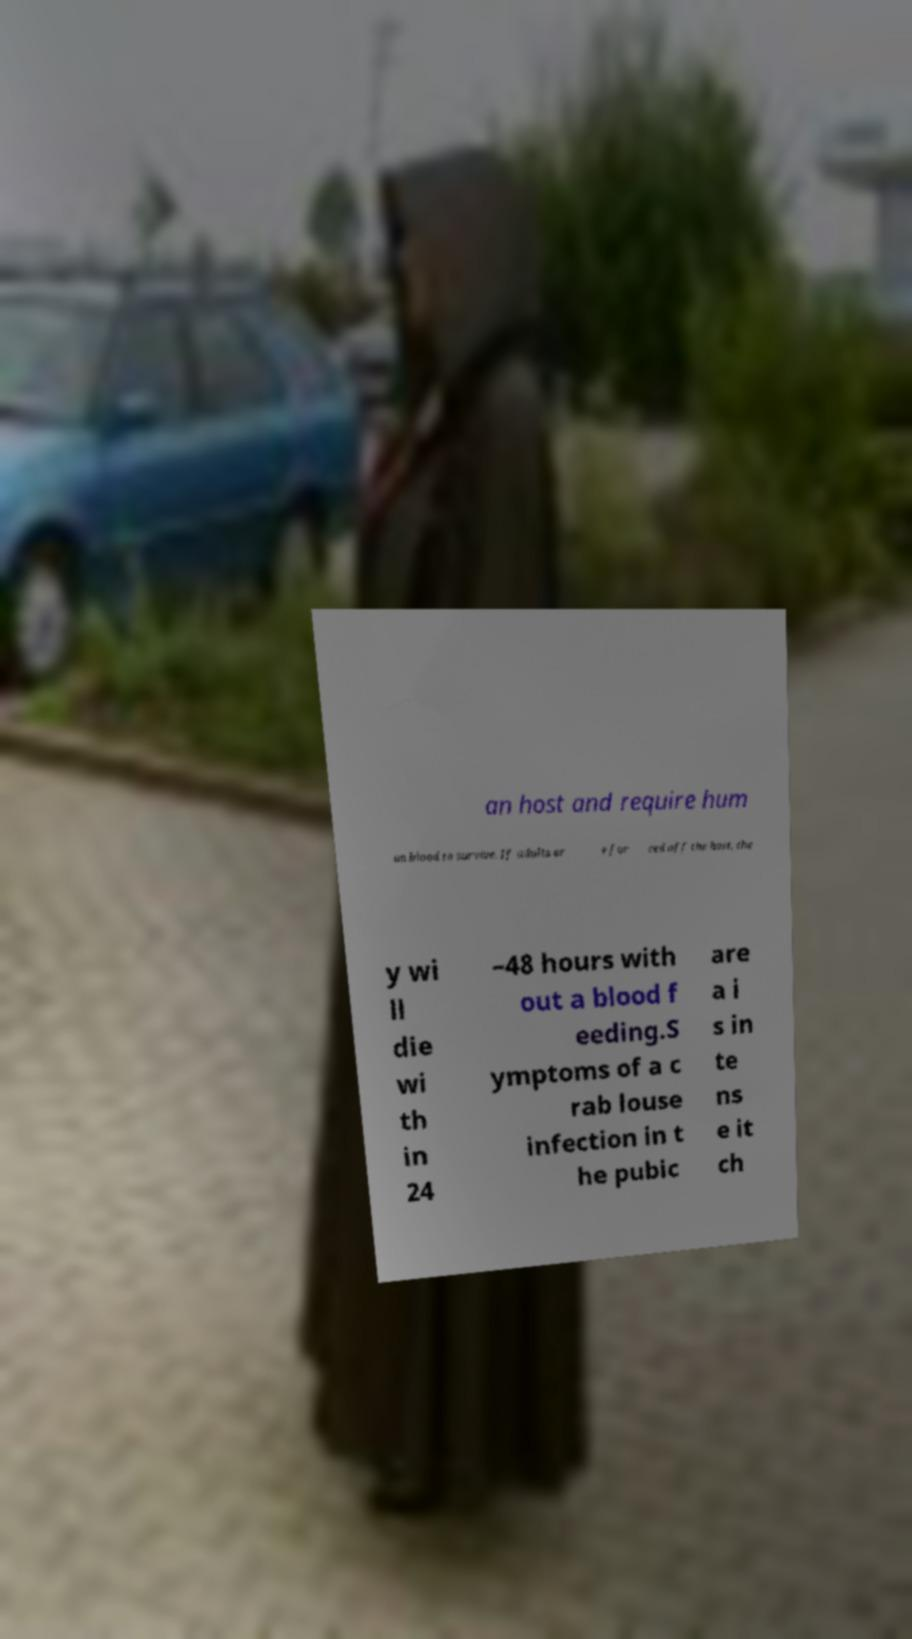Can you read and provide the text displayed in the image?This photo seems to have some interesting text. Can you extract and type it out for me? an host and require hum an blood to survive. If adults ar e for ced off the host, the y wi ll die wi th in 24 –48 hours with out a blood f eeding.S ymptoms of a c rab louse infection in t he pubic are a i s in te ns e it ch 